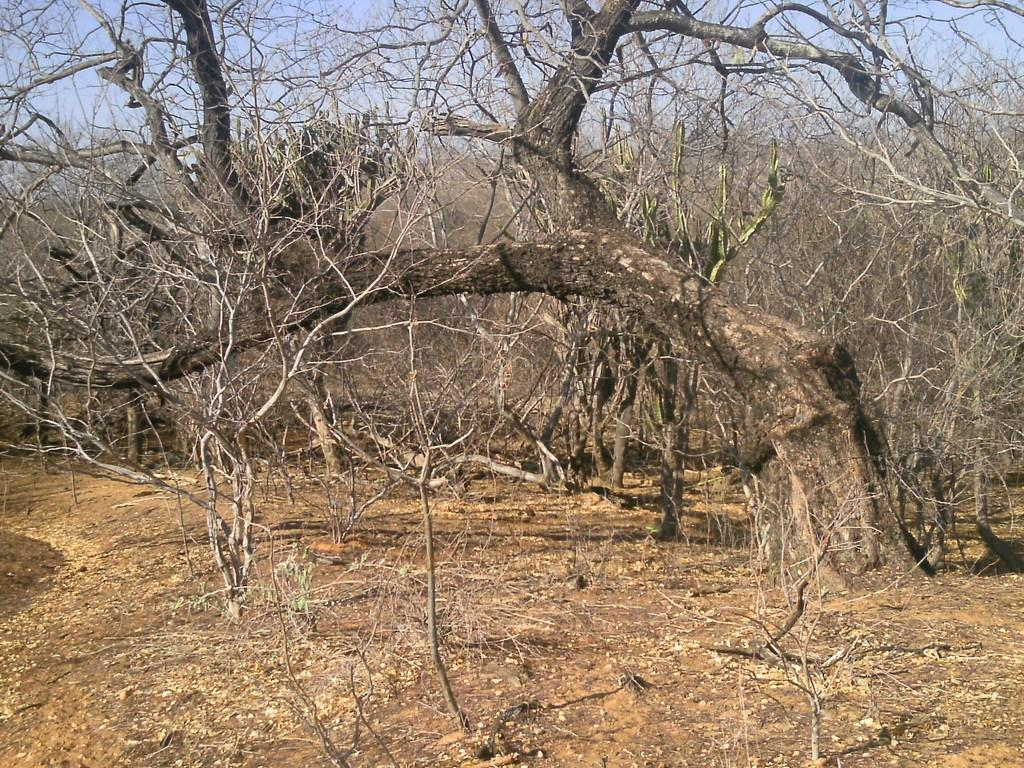What type of vegetation can be seen in the image? There are trees in the image. What part of the natural environment is visible in the image? The ground and the sky are visible in the image. What type of knee injury can be seen in the image? There is no knee injury present in the image; it features trees, ground, and sky. What type of lunch is being served in the image? There is no lunch or any food present in the image. 